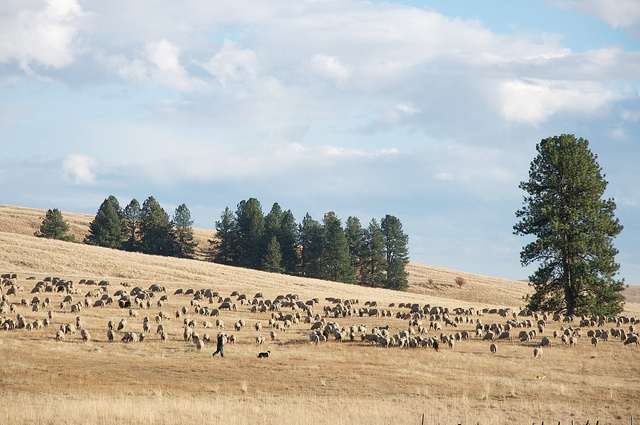Describe the objects in this image and their specific colors. I can see sheep in lightgray, tan, and gray tones, people in lightgray, black, gray, brown, and darkgray tones, sheep in lightgray, black, and gray tones, sheep in lightgray, gray, tan, and black tones, and sheep in lightgray, gray, and tan tones in this image. 